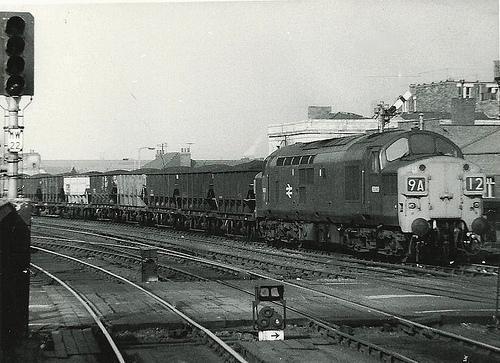How many trains are there?
Give a very brief answer. 1. 